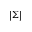Convert formula to latex. <formula><loc_0><loc_0><loc_500><loc_500>| \Sigma |</formula> 